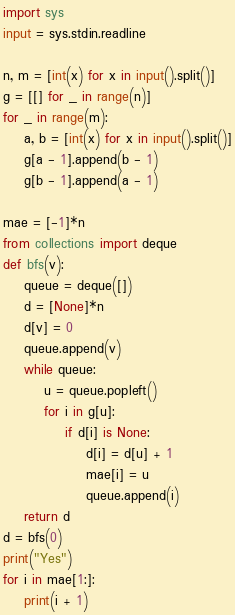Convert code to text. <code><loc_0><loc_0><loc_500><loc_500><_Python_>import sys
input = sys.stdin.readline

n, m = [int(x) for x in input().split()]
g = [[] for _ in range(n)]
for _ in range(m):
    a, b = [int(x) for x in input().split()]
    g[a - 1].append(b - 1)
    g[b - 1].append(a - 1)

mae = [-1]*n
from collections import deque
def bfs(v):
    queue = deque([])
    d = [None]*n
    d[v] = 0
    queue.append(v)
    while queue:
        u = queue.popleft()
        for i in g[u]:
            if d[i] is None:
                d[i] = d[u] + 1
                mae[i] = u
                queue.append(i)
    return d
d = bfs(0)
print("Yes")
for i in mae[1:]:
    print(i + 1)
</code> 